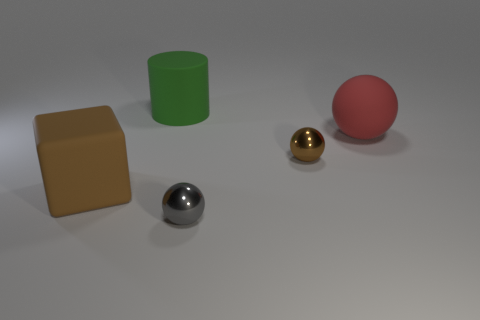Are the tiny ball that is in front of the small brown metallic thing and the brown thing that is behind the brown matte cube made of the same material?
Provide a succinct answer. Yes. What is the shape of the brown matte object that is the same size as the red matte ball?
Offer a very short reply. Cube. How many other things are there of the same color as the cylinder?
Ensure brevity in your answer.  0. What color is the metal ball that is right of the gray shiny thing?
Your answer should be compact. Brown. What number of other objects are the same material as the big brown cube?
Give a very brief answer. 2. Is the number of tiny gray things that are behind the green cylinder greater than the number of big green rubber things that are behind the tiny brown sphere?
Provide a succinct answer. No. How many gray metal spheres are to the left of the brown rubber object?
Provide a short and direct response. 0. Do the cylinder and the object that is on the left side of the big green matte object have the same material?
Offer a terse response. Yes. Is there anything else that is the same shape as the green matte thing?
Provide a short and direct response. No. Does the brown cube have the same material as the large green thing?
Keep it short and to the point. Yes. 